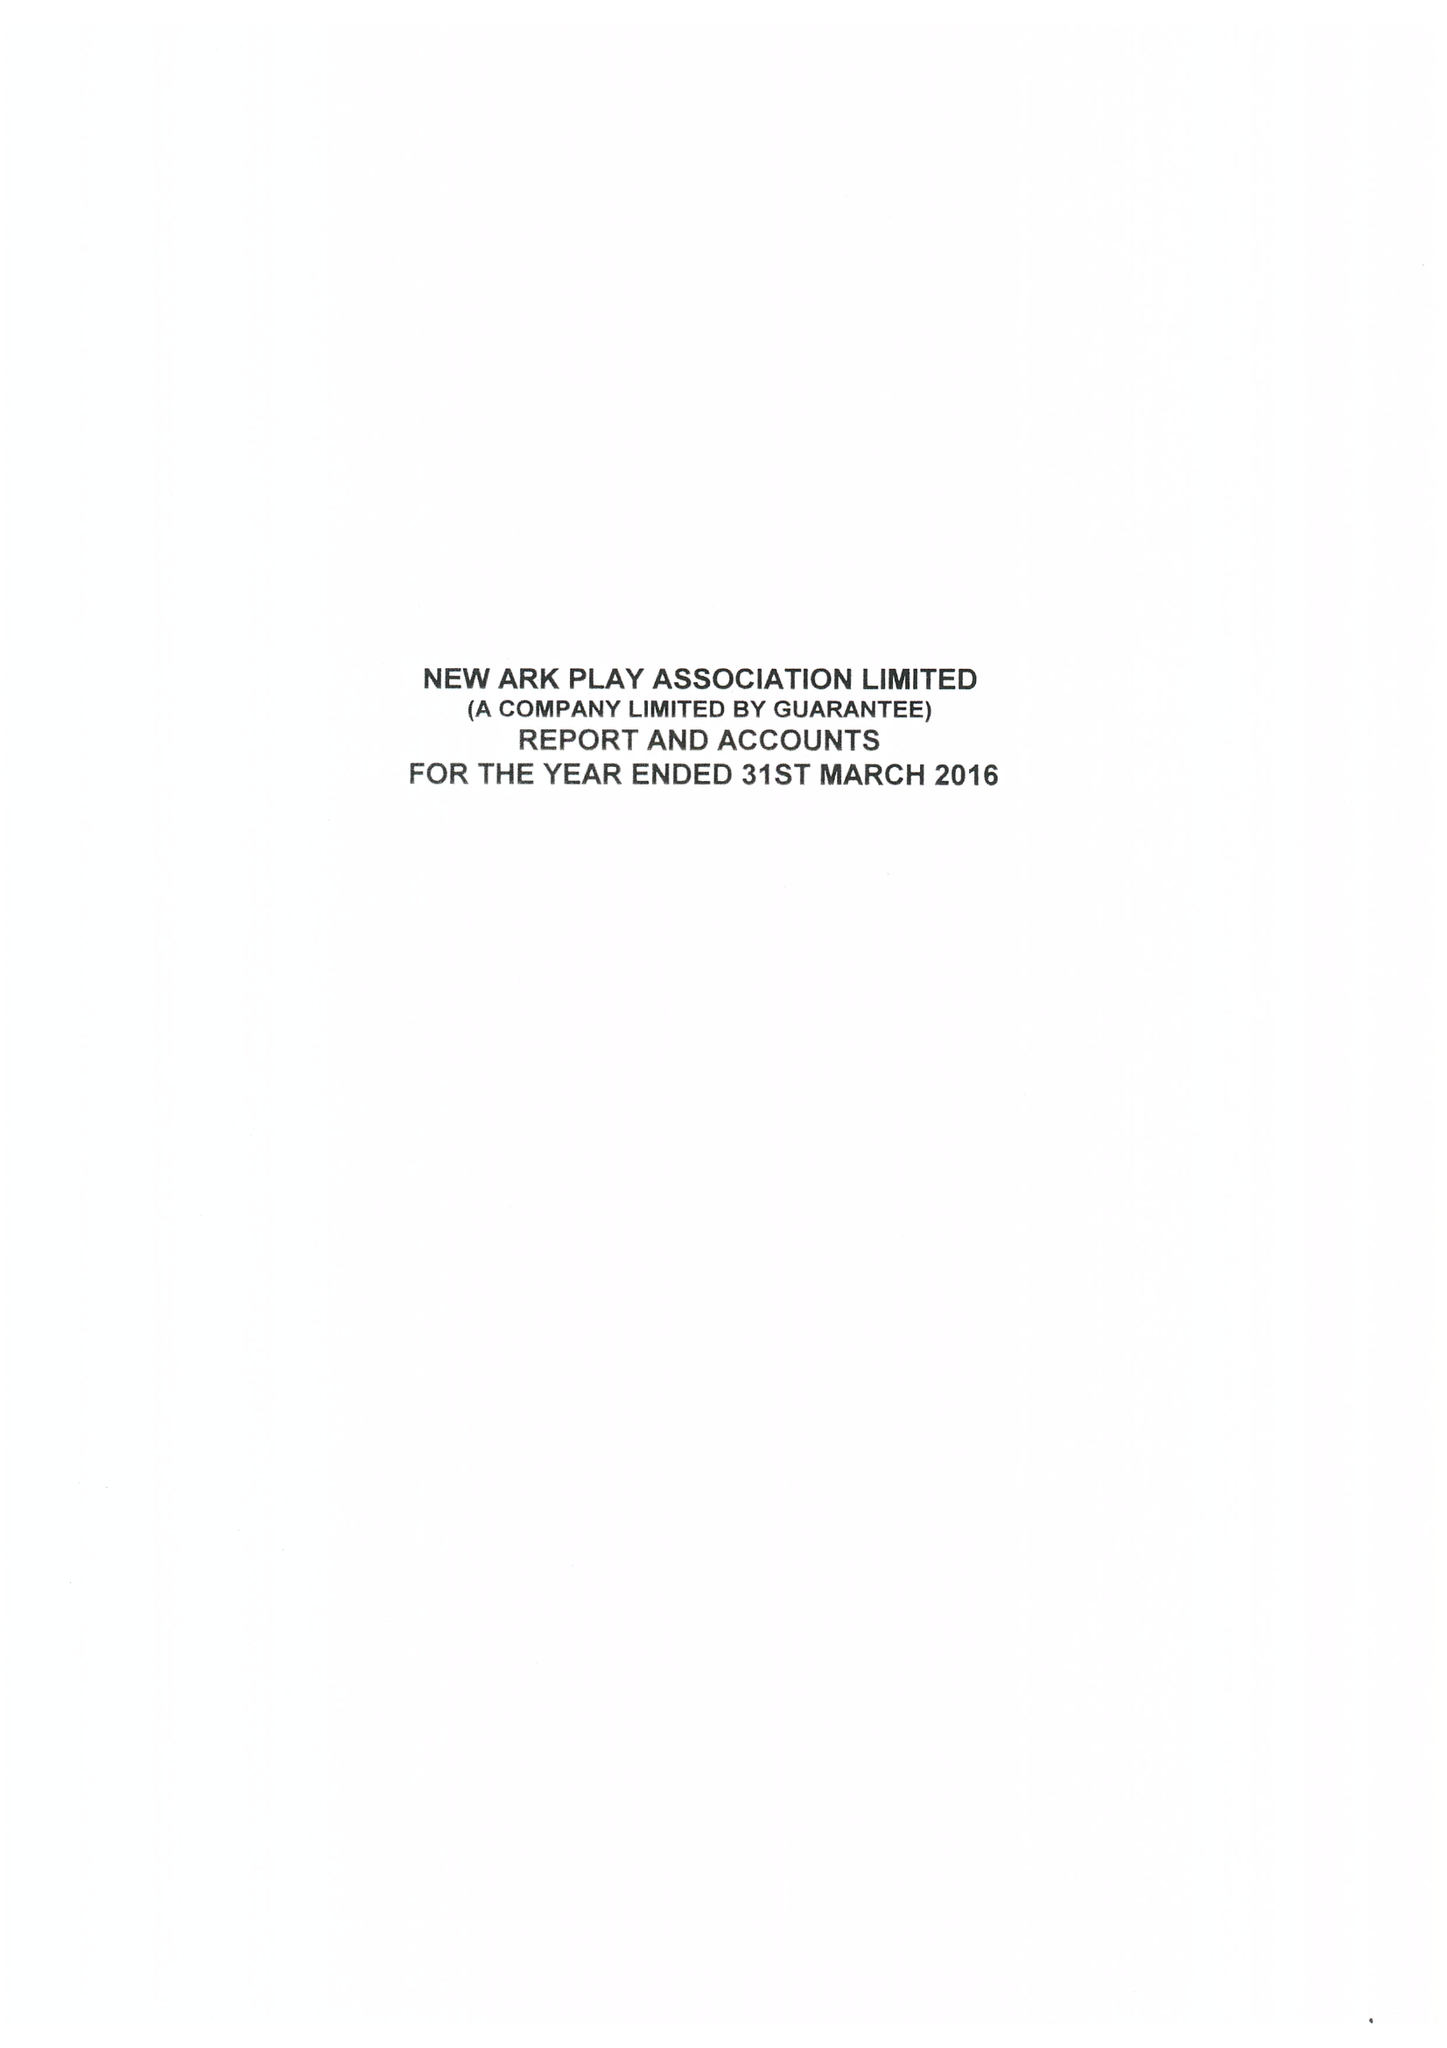What is the value for the income_annually_in_british_pounds?
Answer the question using a single word or phrase. 264050.00 